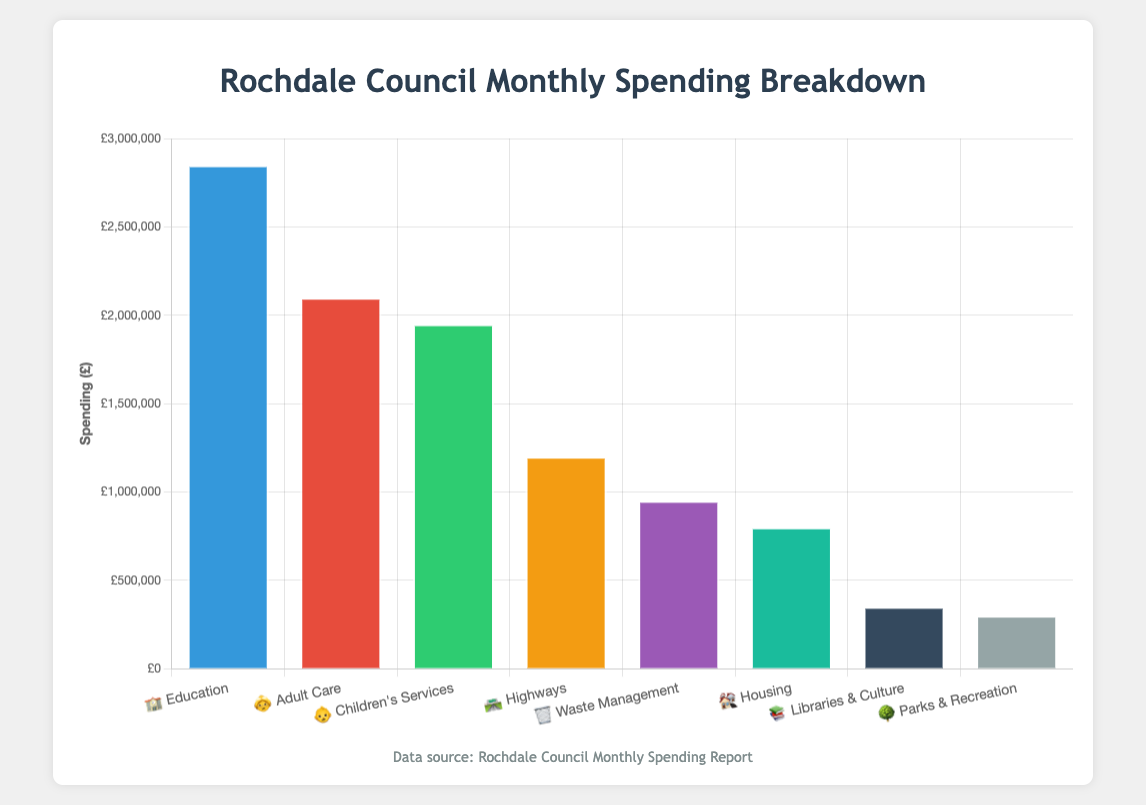what is the title of the chart? The title of the chart is located at the top center of the figure, and it reads "Rochdale Council Monthly Spending Breakdown".
Answer: Rochdale Council Monthly Spending Breakdown Which department has the highest spending? The bar representing the department with the highest spending is the tallest one. The "Education" department, with the emoji 🏫, has the highest bar.
Answer: Education 🏫 How much more does Education 🏫 spend compared to Housing 🏘️? The spending for Education is £2,850,000, while Housing spends £800,000. The difference is £2,850,000 - £800,000 = £2,050,000.
Answer: £2,050,000 What is the total spending on care-related departments? The care-related departments are "Adult Care" and "Children's Services". Their spending is £2,100,000 and £1,950,000 respectively. The total is £2,100,000 + £1,950,000 = £4,050,000.
Answer: £4,050,000 Which department spends more: Highways 🛣️ or Waste Management 🗑️? Highways spends £1,200,000, while Waste Management spends £950,000. Therefore, Highways 🛣️ spends more.
Answer: Highways 🛣️ What is the average spending across all departments? Add up the spending amounts for all departments: £2,850,000 + £2,100,000 + £1,950,000 + £1,200,000 + £950,000 + £800,000 + £350,000 + £300,000 = £10,500,000. There are 8 departments, so the average is £10,500,000 / 8 = £1,312,500.
Answer: £1,312,500 What is the least amount of spending shown on the chart? The shortest bar represents the least amount of spending, which belongs to "Parks & Recreation" 🌳 with £300,000.
Answer: £300,000 Compare the spending on Libraries & Culture 📚 to Parks & Recreation 🌳. Libraries & Culture spends £350,000, while Parks & Recreation spends £300,000. So, Libraries & Culture spends £50,000 more.
Answer: £50,000 more How many departments spend more than £1,000,000 monthly? By examining the bars, "Education", "Adult Care", "Children's Services", and "Highways" each have spending bars above £1,000,000. This gives a total of 4 departments.
Answer: 4 